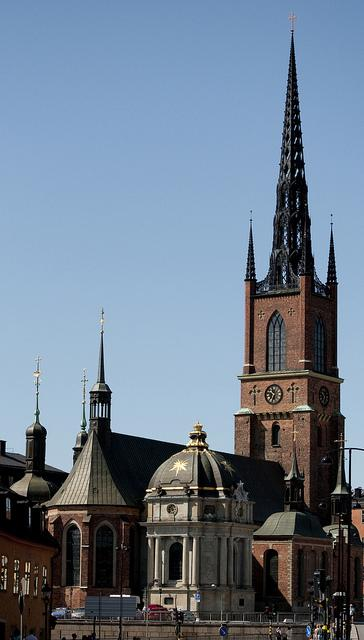What color are the little stars on top of the dome building at the church?

Choices:
A) black
B) white
C) gold
D) blue gold 